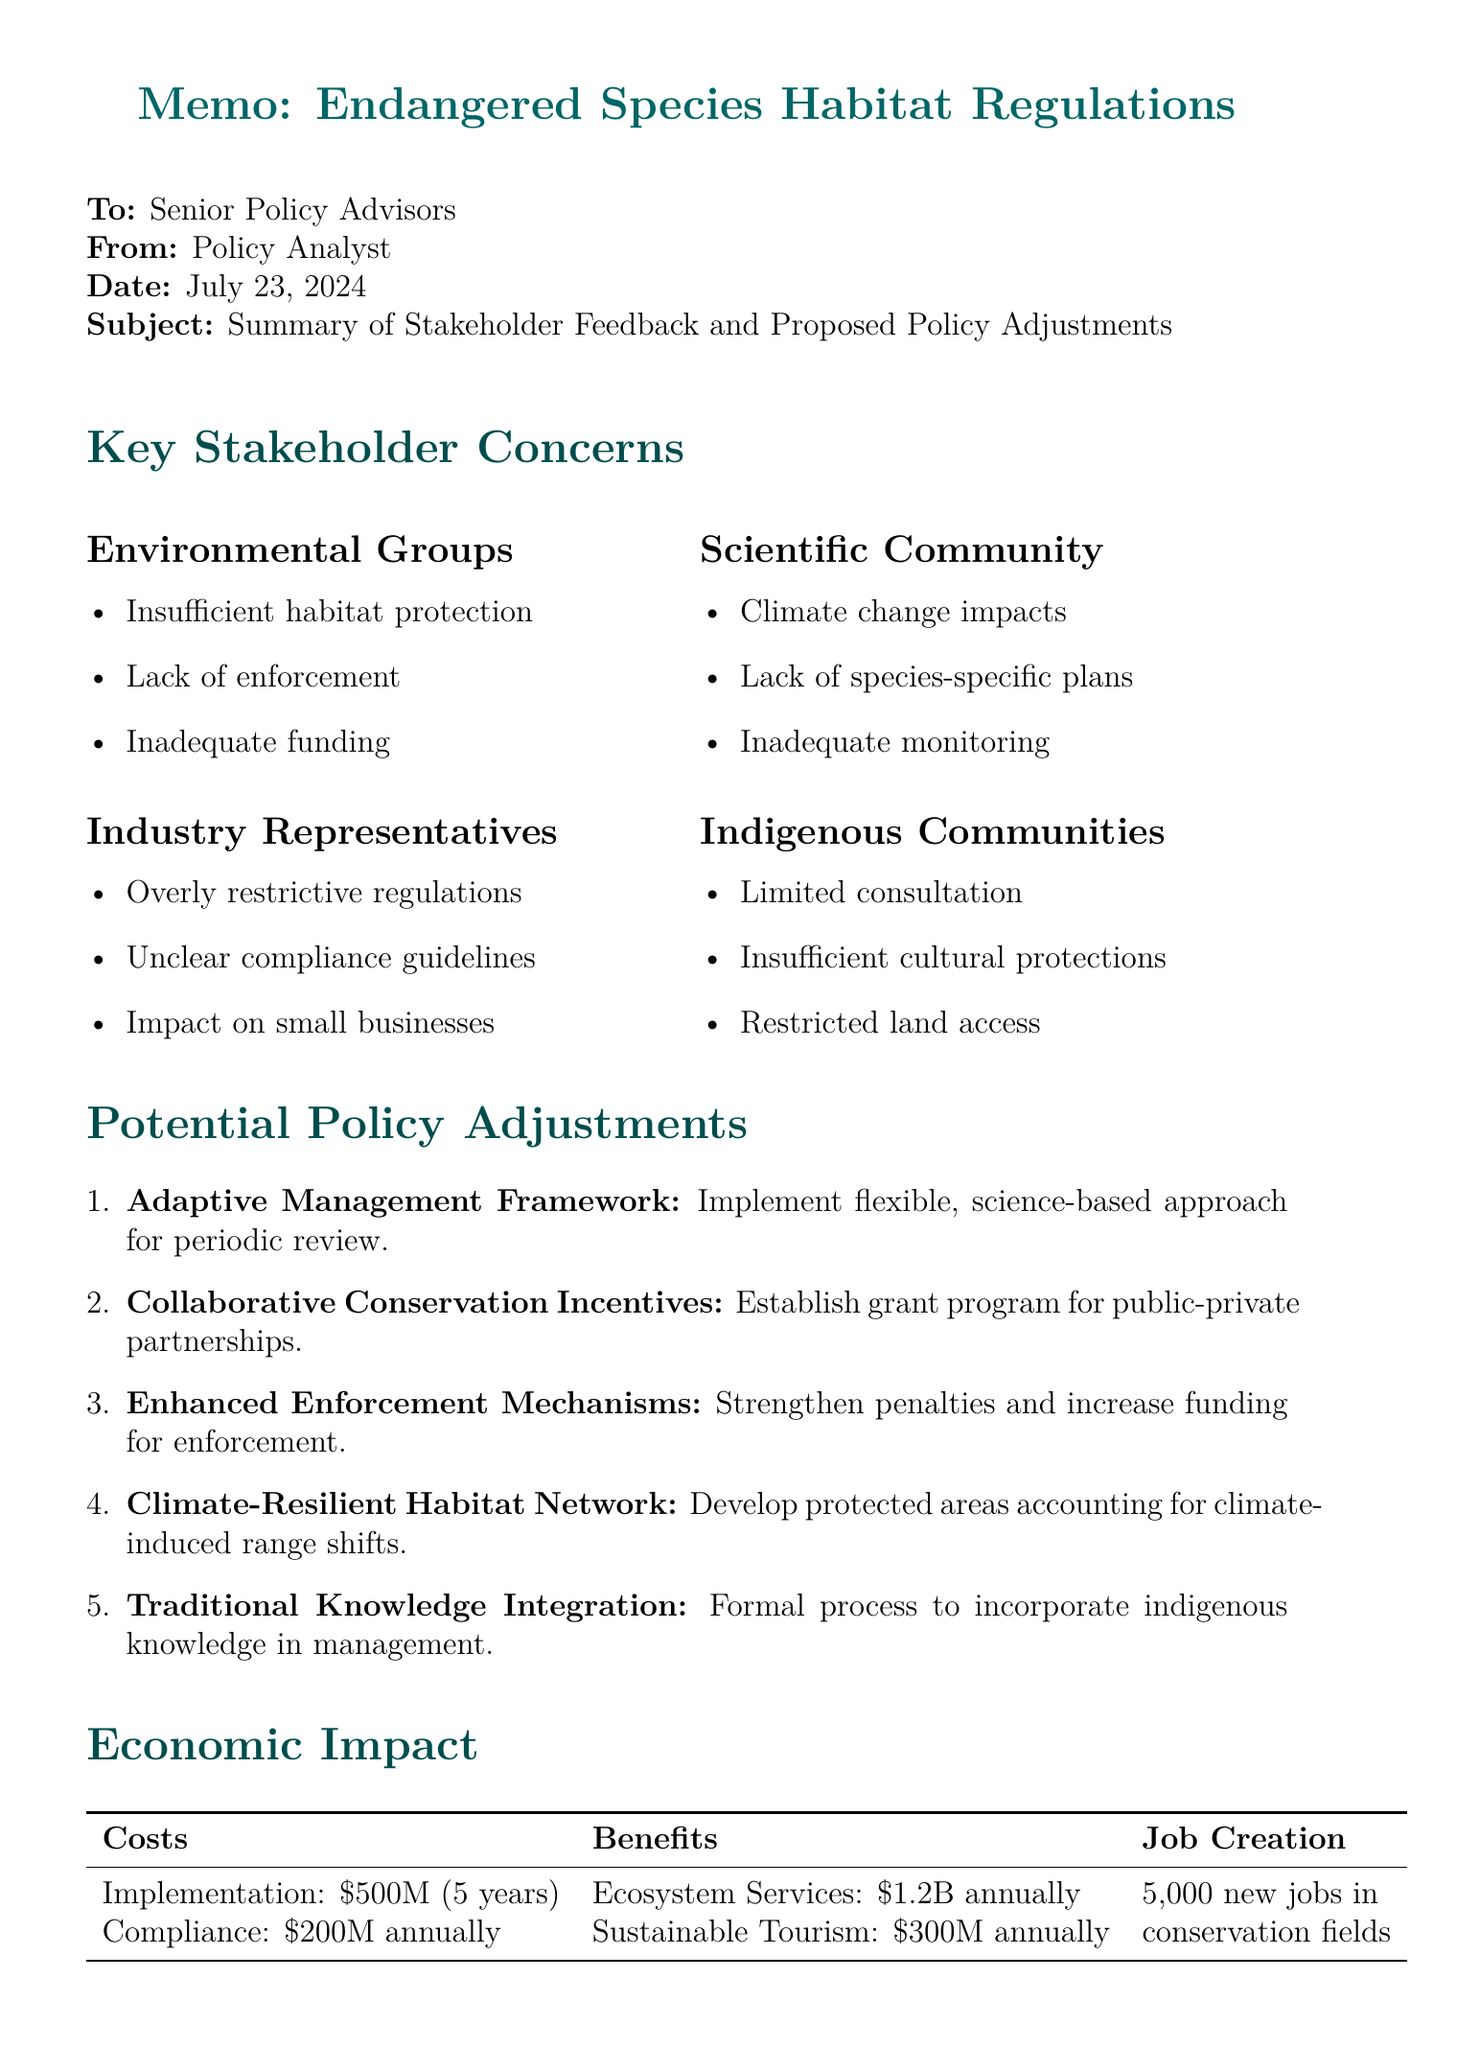what are the key concerns of environmental groups? The document lists three key concerns of environmental groups, which include insufficient habitat protection, lack of enforcement, and inadequate funding.
Answer: insufficient habitat protection, lack of enforcement, inadequate funding how much is the estimated cost for implementation over five years? The document states that the estimated cost for implementation is $500 million over five years.
Answer: $500 million what is one recommendation from the scientific community? The document includes multiple recommendations from the scientific community, one of which is to incorporate climate change projections into habitat designations.
Answer: incorporate climate change projections into habitat designations what is the potential benefit of ecosystem services? The document mentions the potential benefits of ecosystem services as $1.2 billion annually.
Answer: $1.2 billion annually how many new jobs are estimated to be created in conservation and related fields? According to the document, the estimated job creation in conservation and related fields is 5,000 new jobs.
Answer: 5,000 what is the title of the first potential policy adjustment? The document lists the first potential policy adjustment as "Adaptive Management Framework."
Answer: Adaptive Management Framework what issue is highlighted by industry representatives regarding regulations? The document indicates that industry representatives have concerns about overly restrictive regulations hindering economic development.
Answer: overly restrictive regulations hindering economic development which international agreement is mentioned in the document? The document lists three relevant international agreements, one of which is the Convention on Biological Diversity.
Answer: Convention on Biological Diversity what type of management does the "Traditional Knowledge Integration" policy suggest? The document states that the "Traditional Knowledge Integration" policy suggests a formal process for incorporating indigenous and local knowledge into habitat management decisions.
Answer: formal process for incorporating indigenous and local knowledge into habitat management decisions 